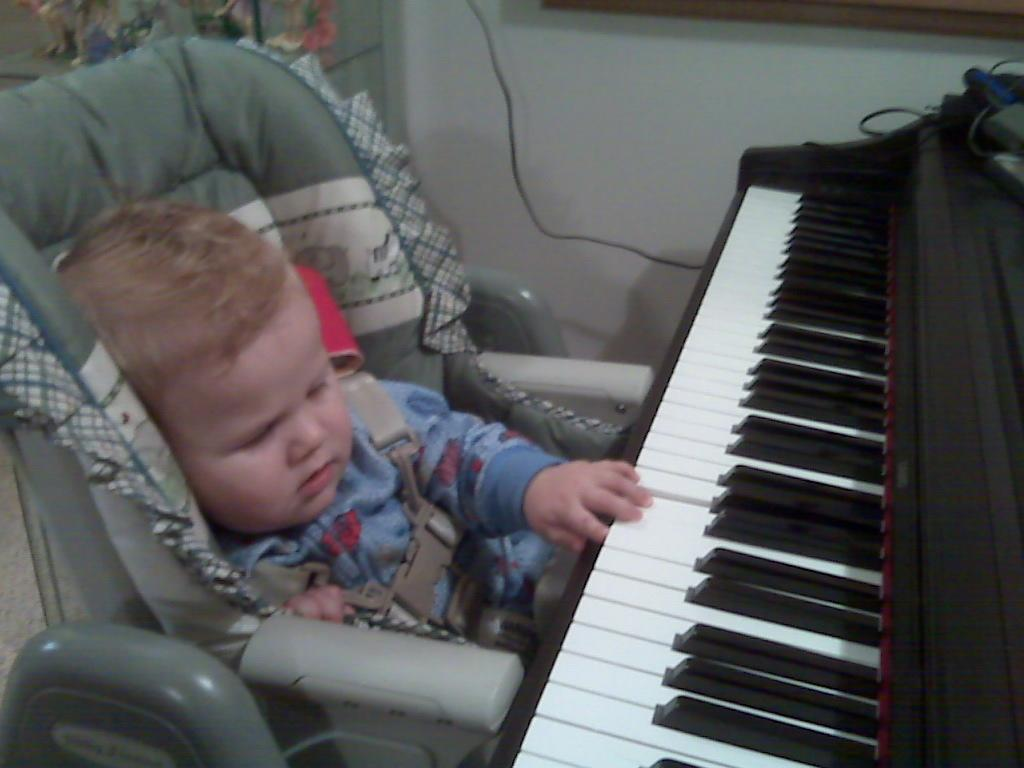Who is the main subject in the image? There is a boy in the image. What is the boy doing in the image? The boy is sitting on a chair and holding a piano. Can you describe any other objects in the image? There is a wire in the image, and there are showpieces on a shelf. What is the boy's belief about the stitch in the image? There is no mention of a stitch or any beliefs in the image. The boy is holding a piano and sitting on a chair. 